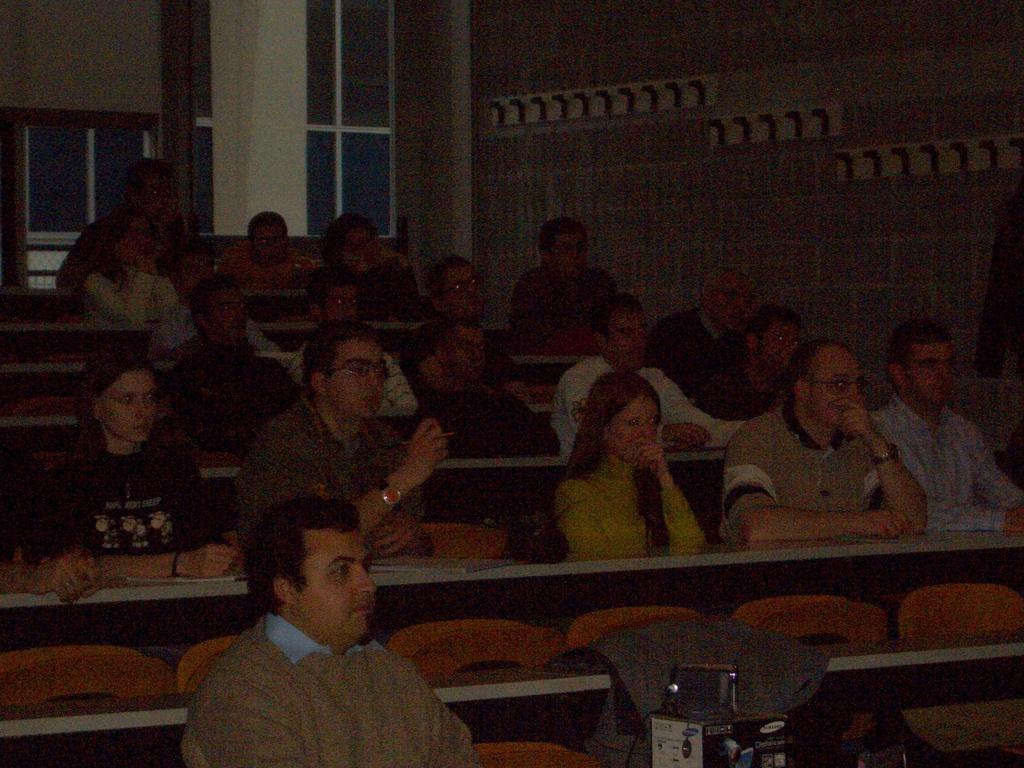How many people are in the image? There is a group of people in the image. What are the people doing in the image? The people are sitting on chairs. What other objects can be seen in the image besides the people? There are tables, a box, a wall, a pillar, and windows in the image. What type of advice can be seen written on the wall in the image? There is no advice written on the wall in the image; it only shows a group of people sitting on chairs, tables, a box, a wall, a pillar, and windows. 